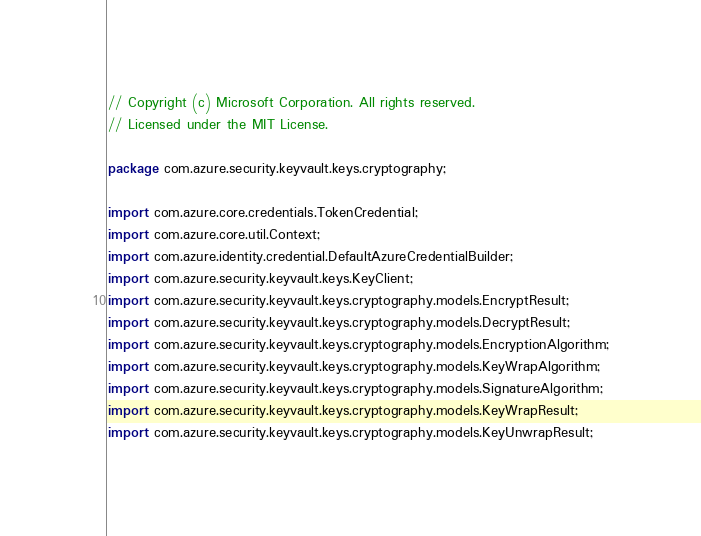<code> <loc_0><loc_0><loc_500><loc_500><_Java_>// Copyright (c) Microsoft Corporation. All rights reserved.
// Licensed under the MIT License.

package com.azure.security.keyvault.keys.cryptography;

import com.azure.core.credentials.TokenCredential;
import com.azure.core.util.Context;
import com.azure.identity.credential.DefaultAzureCredentialBuilder;
import com.azure.security.keyvault.keys.KeyClient;
import com.azure.security.keyvault.keys.cryptography.models.EncryptResult;
import com.azure.security.keyvault.keys.cryptography.models.DecryptResult;
import com.azure.security.keyvault.keys.cryptography.models.EncryptionAlgorithm;
import com.azure.security.keyvault.keys.cryptography.models.KeyWrapAlgorithm;
import com.azure.security.keyvault.keys.cryptography.models.SignatureAlgorithm;
import com.azure.security.keyvault.keys.cryptography.models.KeyWrapResult;
import com.azure.security.keyvault.keys.cryptography.models.KeyUnwrapResult;</code> 